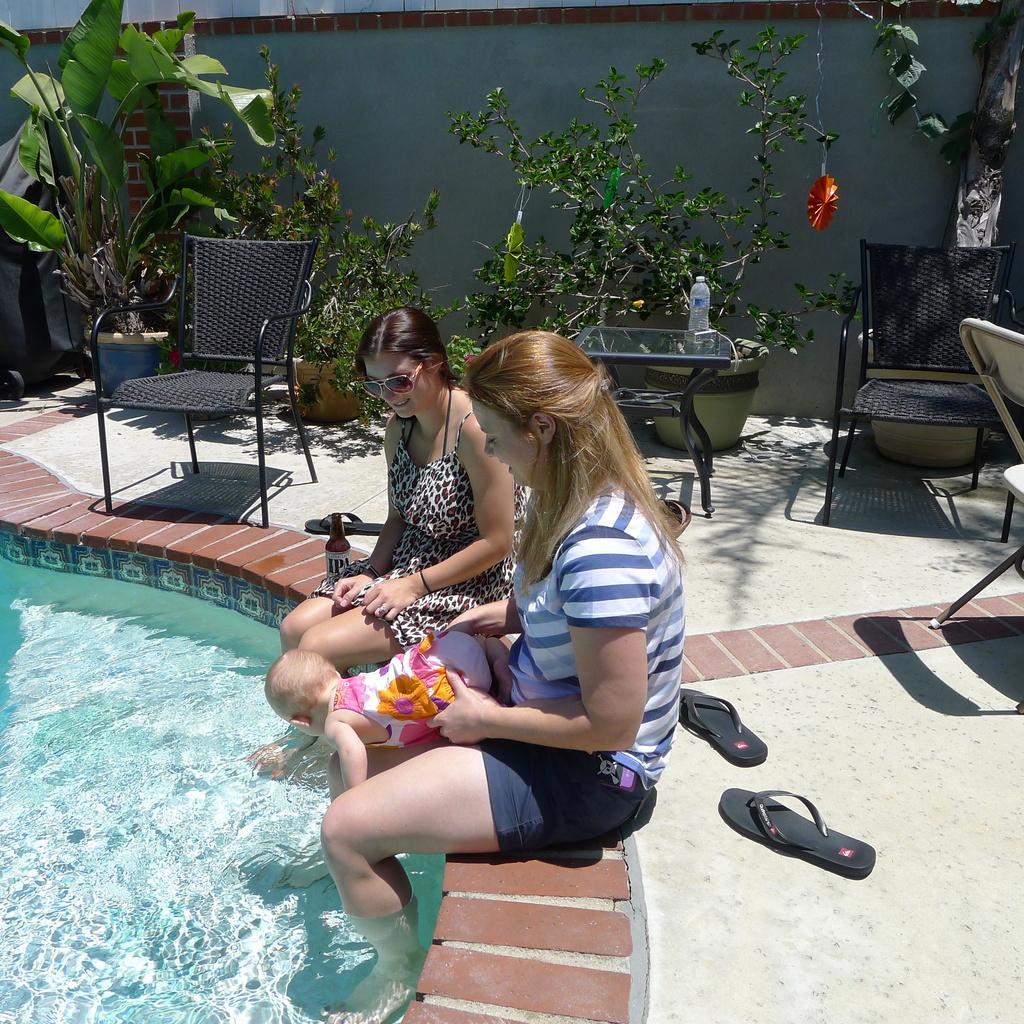Please provide a concise description of this image. In this image we can see women sitting on the pavement of the pool and holding a baby. In the background we can see plants, chairs, side tables, slippers and walls. 